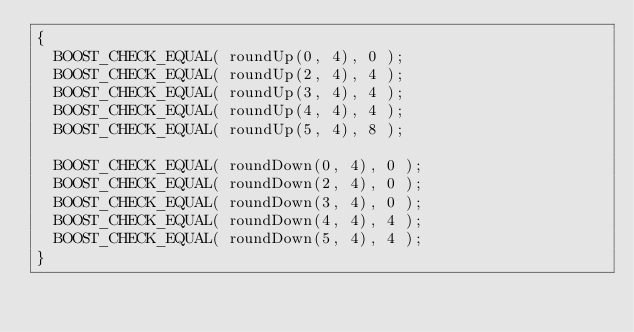<code> <loc_0><loc_0><loc_500><loc_500><_C++_>{
	BOOST_CHECK_EQUAL( roundUp(0, 4), 0 );
	BOOST_CHECK_EQUAL( roundUp(2, 4), 4 );
	BOOST_CHECK_EQUAL( roundUp(3, 4), 4 );
	BOOST_CHECK_EQUAL( roundUp(4, 4), 4 );
	BOOST_CHECK_EQUAL( roundUp(5, 4), 8 );

	BOOST_CHECK_EQUAL( roundDown(0, 4), 0 );
	BOOST_CHECK_EQUAL( roundDown(2, 4), 0 );
	BOOST_CHECK_EQUAL( roundDown(3, 4), 0 );
	BOOST_CHECK_EQUAL( roundDown(4, 4), 4 );
	BOOST_CHECK_EQUAL( roundDown(5, 4), 4 );
}
</code> 